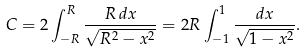Convert formula to latex. <formula><loc_0><loc_0><loc_500><loc_500>C = 2 \int _ { - R } ^ { R } { \frac { R \, d x } { \sqrt { R ^ { 2 } - x ^ { 2 } } } } = 2 R \int _ { - 1 } ^ { 1 } { \frac { d x } { \sqrt { 1 - x ^ { 2 } } } } .</formula> 